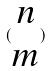Convert formula to latex. <formula><loc_0><loc_0><loc_500><loc_500>( \begin{matrix} n \\ m \end{matrix} )</formula> 